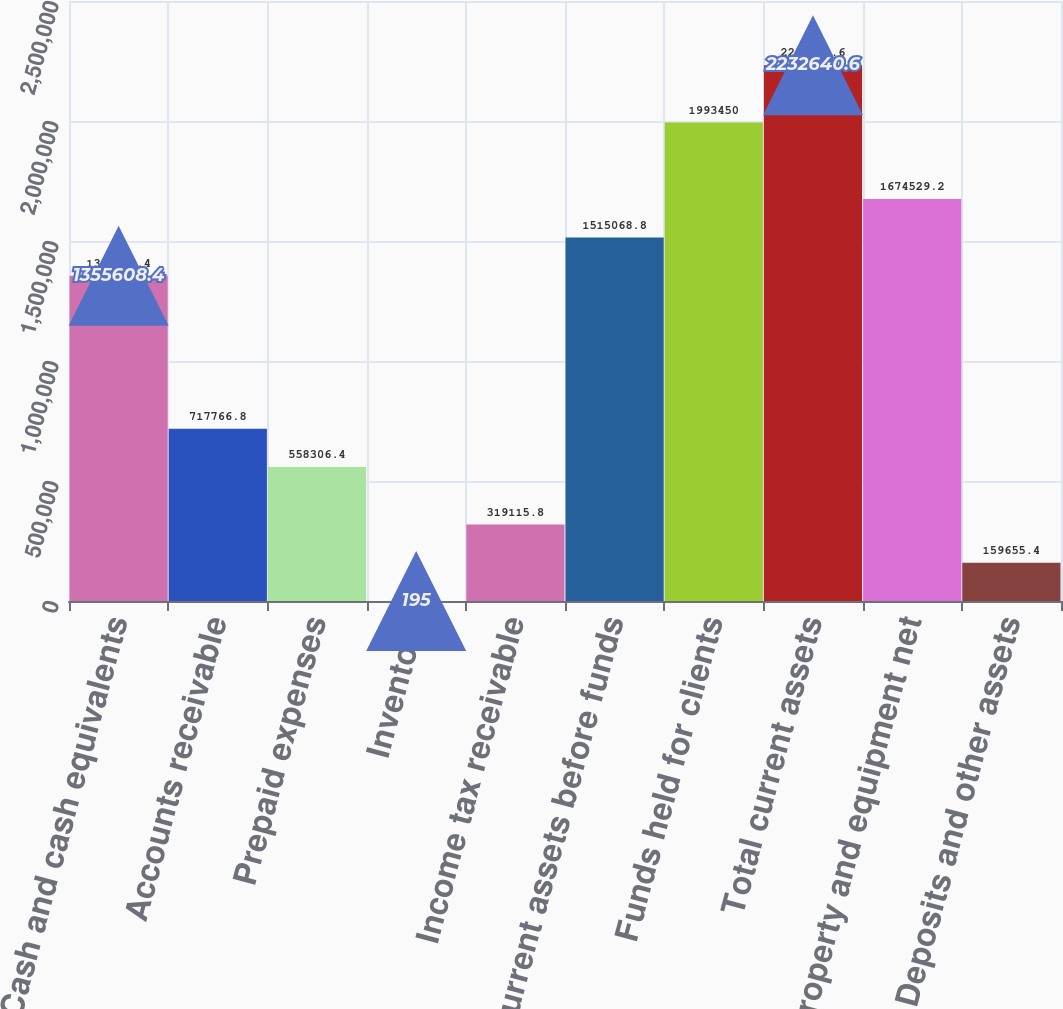Convert chart to OTSL. <chart><loc_0><loc_0><loc_500><loc_500><bar_chart><fcel>Cash and cash equivalents<fcel>Accounts receivable<fcel>Prepaid expenses<fcel>Inventory<fcel>Income tax receivable<fcel>Current assets before funds<fcel>Funds held for clients<fcel>Total current assets<fcel>Property and equipment net<fcel>Deposits and other assets<nl><fcel>1.35561e+06<fcel>717767<fcel>558306<fcel>195<fcel>319116<fcel>1.51507e+06<fcel>1.99345e+06<fcel>2.23264e+06<fcel>1.67453e+06<fcel>159655<nl></chart> 